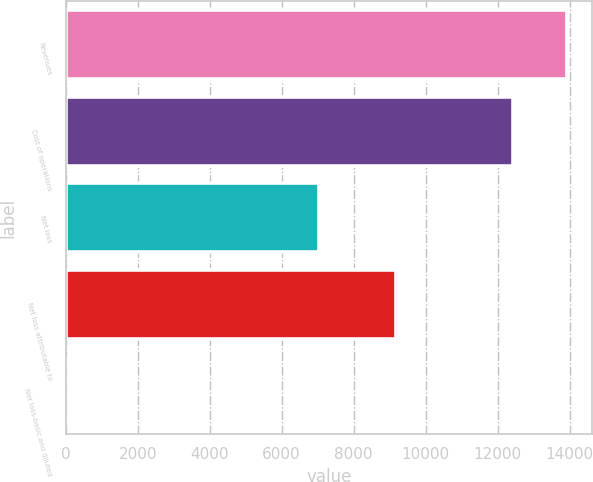Convert chart to OTSL. <chart><loc_0><loc_0><loc_500><loc_500><bar_chart><fcel>Revenues<fcel>Cost of operations<fcel>Net loss<fcel>Net loss attributable to<fcel>Net loss-basic and diluted<nl><fcel>13929<fcel>12428<fcel>7036<fcel>9183<fcel>1.49<nl></chart> 